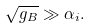Convert formula to latex. <formula><loc_0><loc_0><loc_500><loc_500>\sqrt { g _ { B } } \gg \alpha _ { i } .</formula> 